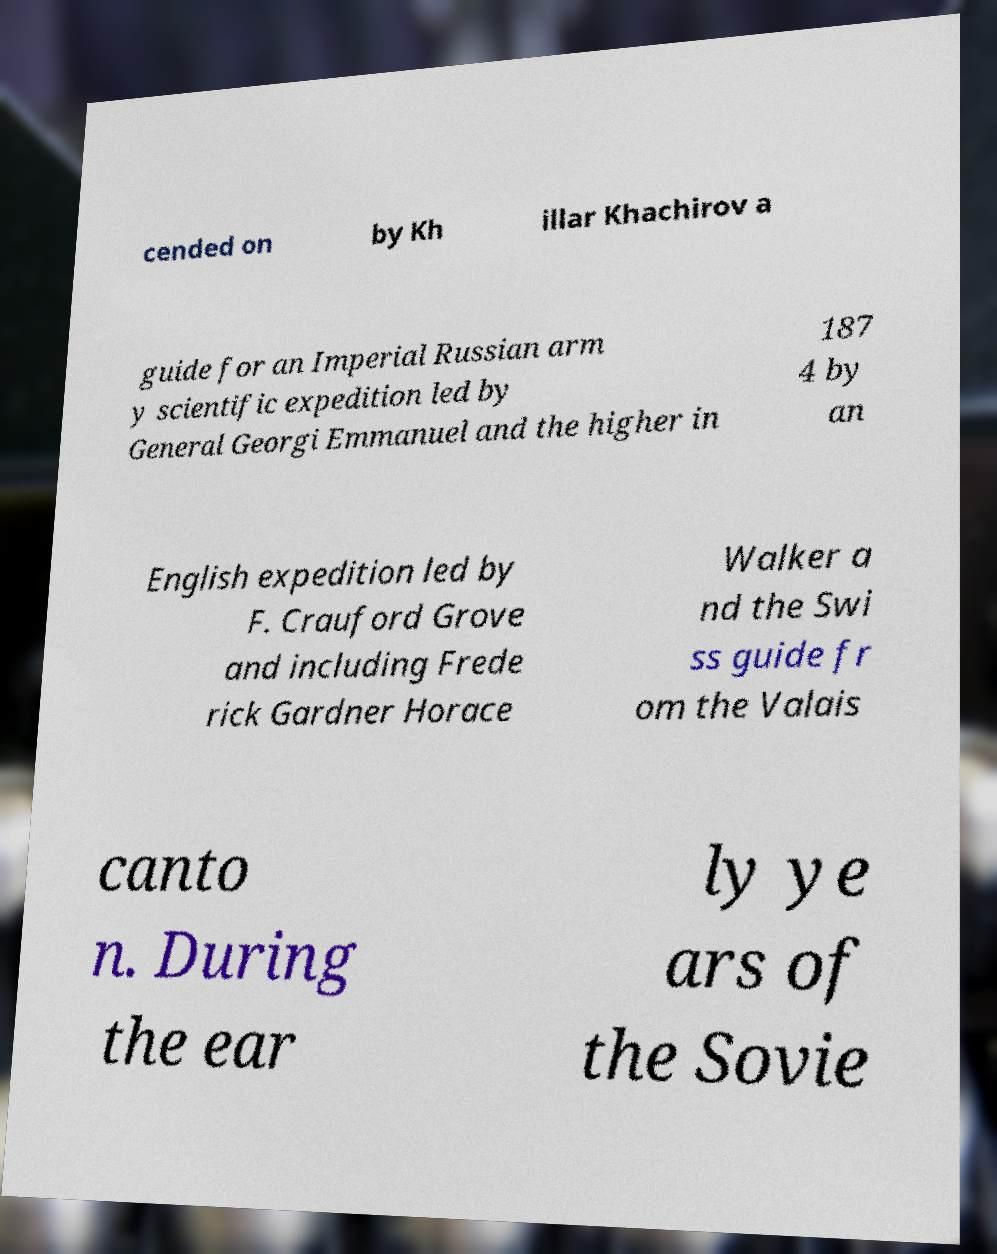For documentation purposes, I need the text within this image transcribed. Could you provide that? cended on by Kh illar Khachirov a guide for an Imperial Russian arm y scientific expedition led by General Georgi Emmanuel and the higher in 187 4 by an English expedition led by F. Crauford Grove and including Frede rick Gardner Horace Walker a nd the Swi ss guide fr om the Valais canto n. During the ear ly ye ars of the Sovie 